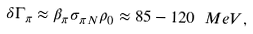<formula> <loc_0><loc_0><loc_500><loc_500>\delta \Gamma _ { \pi } \approx \beta _ { \pi } \sigma _ { \pi N } \rho _ { 0 } \approx 8 5 - 1 2 0 \ M e V ,</formula> 